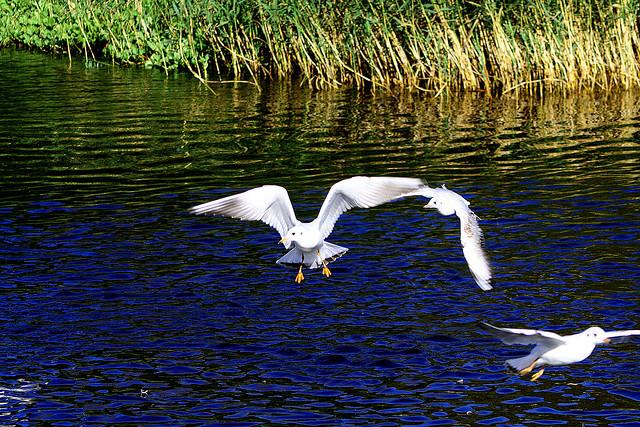How many white birds are flying?
Be succinct. 3. Is there foliage in the background?
Quick response, please. Yes. What are the birds flying over?
Be succinct. Water. 